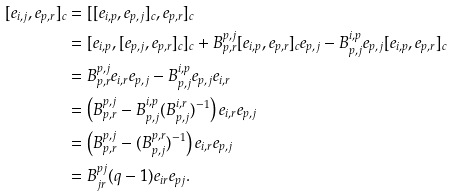<formula> <loc_0><loc_0><loc_500><loc_500>[ e _ { i , j } , e _ { p , r } ] _ { c } & = [ [ e _ { i , p } , e _ { p , j } ] _ { c } , e _ { p , r } ] _ { c } \\ & = [ e _ { i , p } , [ e _ { p , j } , e _ { p , r } ] _ { c } ] _ { c } + B _ { p , r } ^ { p , j } [ e _ { i , p } , e _ { p , r } ] _ { c } e _ { p , j } - B _ { p , j } ^ { i , p } e _ { p , j } [ e _ { i , p } , e _ { p , r } ] _ { c } \\ & = B _ { p , r } ^ { p , j } e _ { i , r } e _ { p , j } - B _ { p , j } ^ { i , p } e _ { p , j } e _ { i , r } \\ & = \left ( B _ { p , r } ^ { p , j } - B _ { p , j } ^ { i , p } ( B _ { p , j } ^ { i , r } ) ^ { - 1 } \right ) e _ { i , r } e _ { p , j } \\ & = \left ( B _ { p , r } ^ { p , j } - ( B _ { p , j } ^ { p , r } ) ^ { - 1 } \right ) e _ { i , r } e _ { p , j } \\ & = B ^ { p j } _ { j r } ( q - 1 ) e _ { i r } e _ { p j } .</formula> 